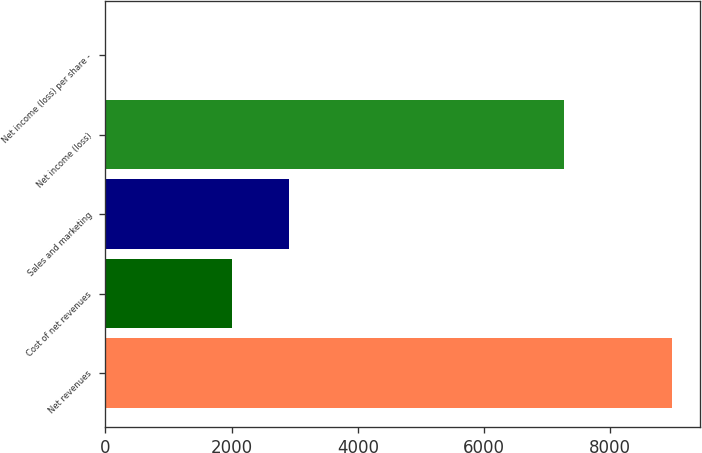<chart> <loc_0><loc_0><loc_500><loc_500><bar_chart><fcel>Net revenues<fcel>Cost of net revenues<fcel>Sales and marketing<fcel>Net income (loss)<fcel>Net income (loss) per share -<nl><fcel>8979<fcel>2007<fcel>2904.26<fcel>7266<fcel>6.35<nl></chart> 